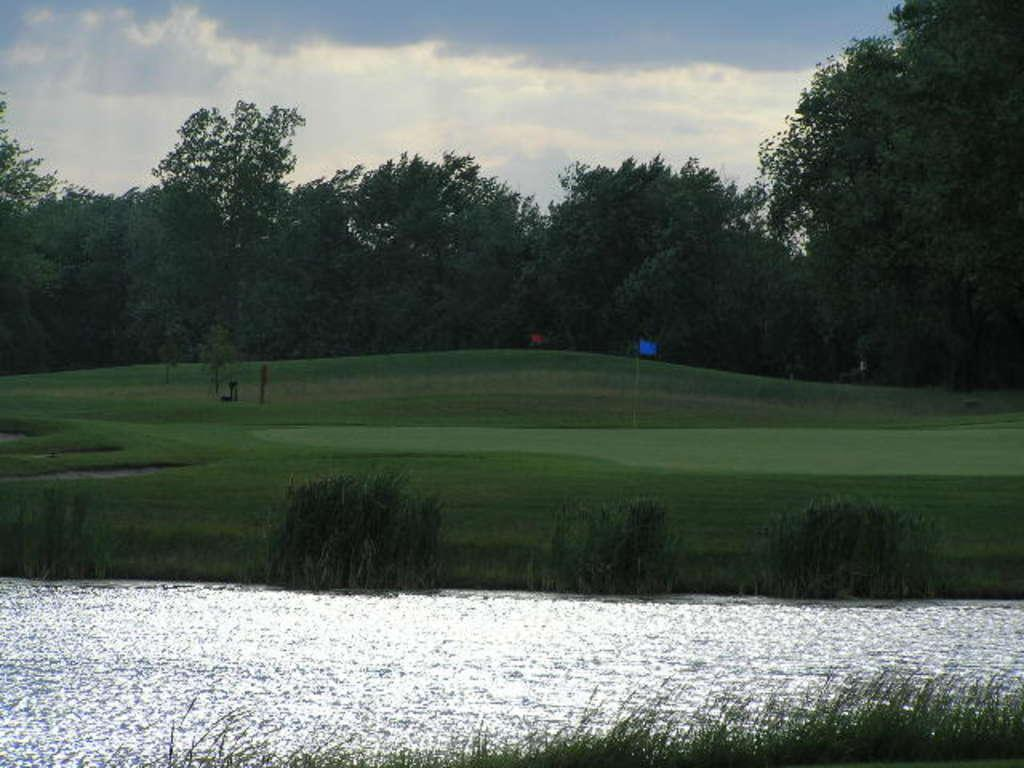What type of vegetation is present in the image? There is grass and plants in the image. What else can be seen in the image besides vegetation? There is water and a flag in the background of the image. What is visible in the background of the image? The sky and other objects on the ground are visible in the background of the image. Can you see your friend holding an apple in the image? There is no friend or apple present in the image. Is there any thread visible in the image? There is no thread visible in the image. 